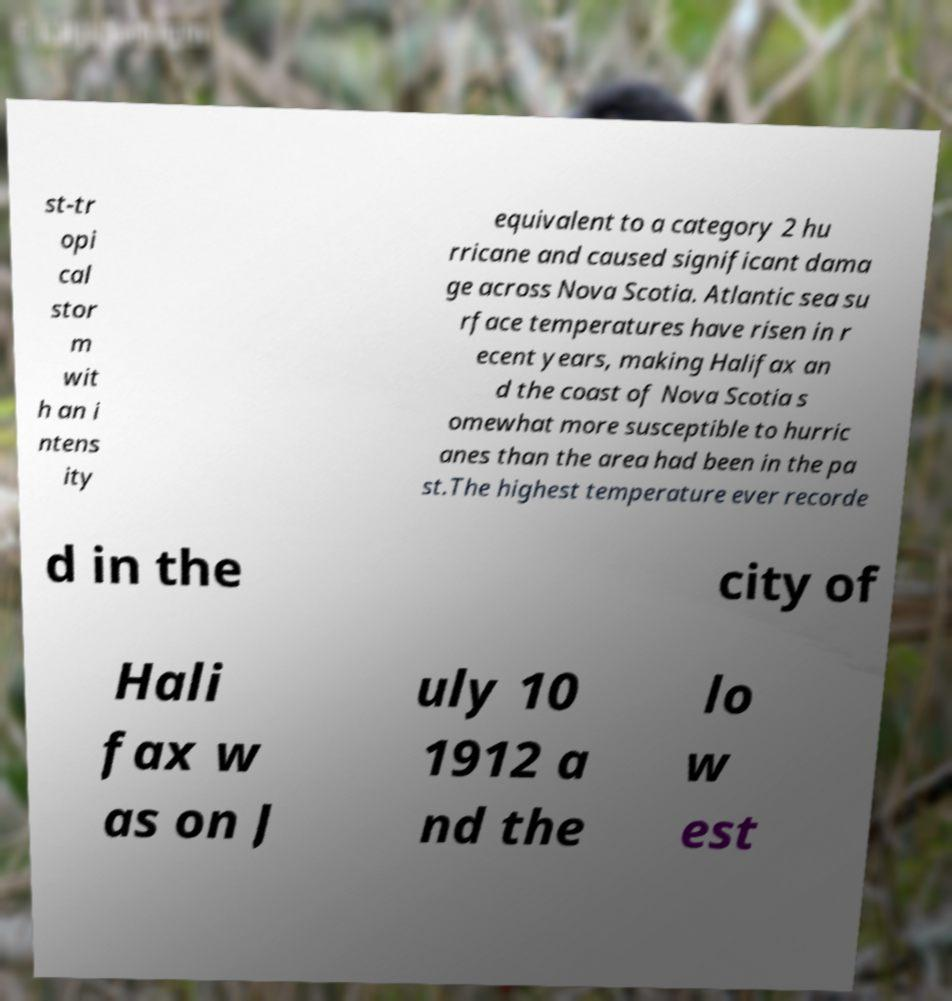Could you assist in decoding the text presented in this image and type it out clearly? st-tr opi cal stor m wit h an i ntens ity equivalent to a category 2 hu rricane and caused significant dama ge across Nova Scotia. Atlantic sea su rface temperatures have risen in r ecent years, making Halifax an d the coast of Nova Scotia s omewhat more susceptible to hurric anes than the area had been in the pa st.The highest temperature ever recorde d in the city of Hali fax w as on J uly 10 1912 a nd the lo w est 